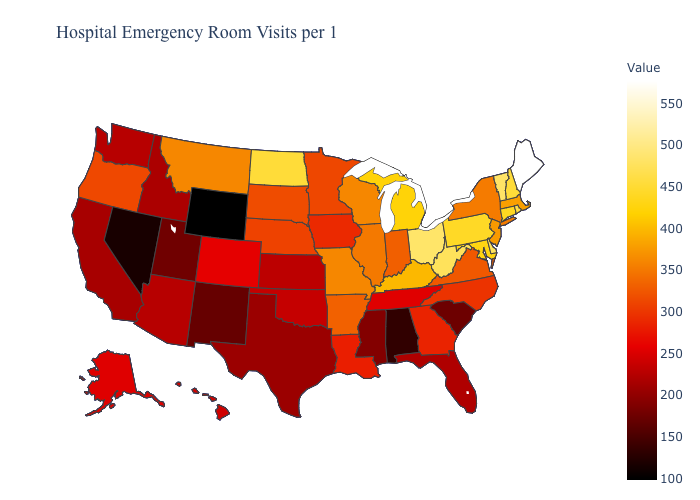Does Maine have the highest value in the USA?
Quick response, please. Yes. Among the states that border Louisiana , does Mississippi have the lowest value?
Answer briefly. Yes. Which states have the lowest value in the USA?
Quick response, please. Wyoming. Does the map have missing data?
Answer briefly. No. 